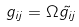Convert formula to latex. <formula><loc_0><loc_0><loc_500><loc_500>g _ { i j } = \Omega \tilde { g _ { i j } }</formula> 